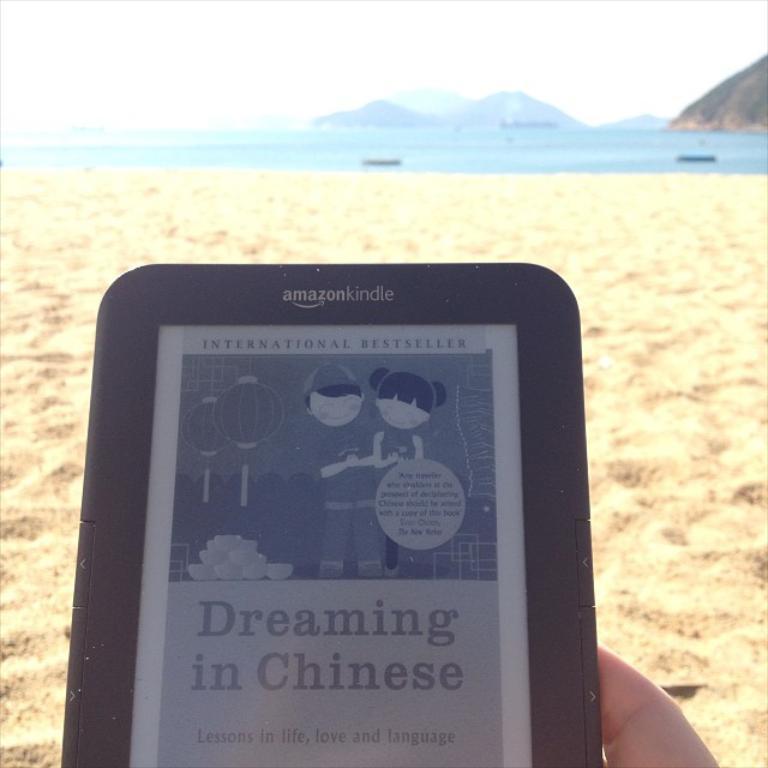Can you describe this image briefly? As we can see in the image there is a human hand holding tablet and there is sand. In the background there is water and hills. On the top there is sky. 